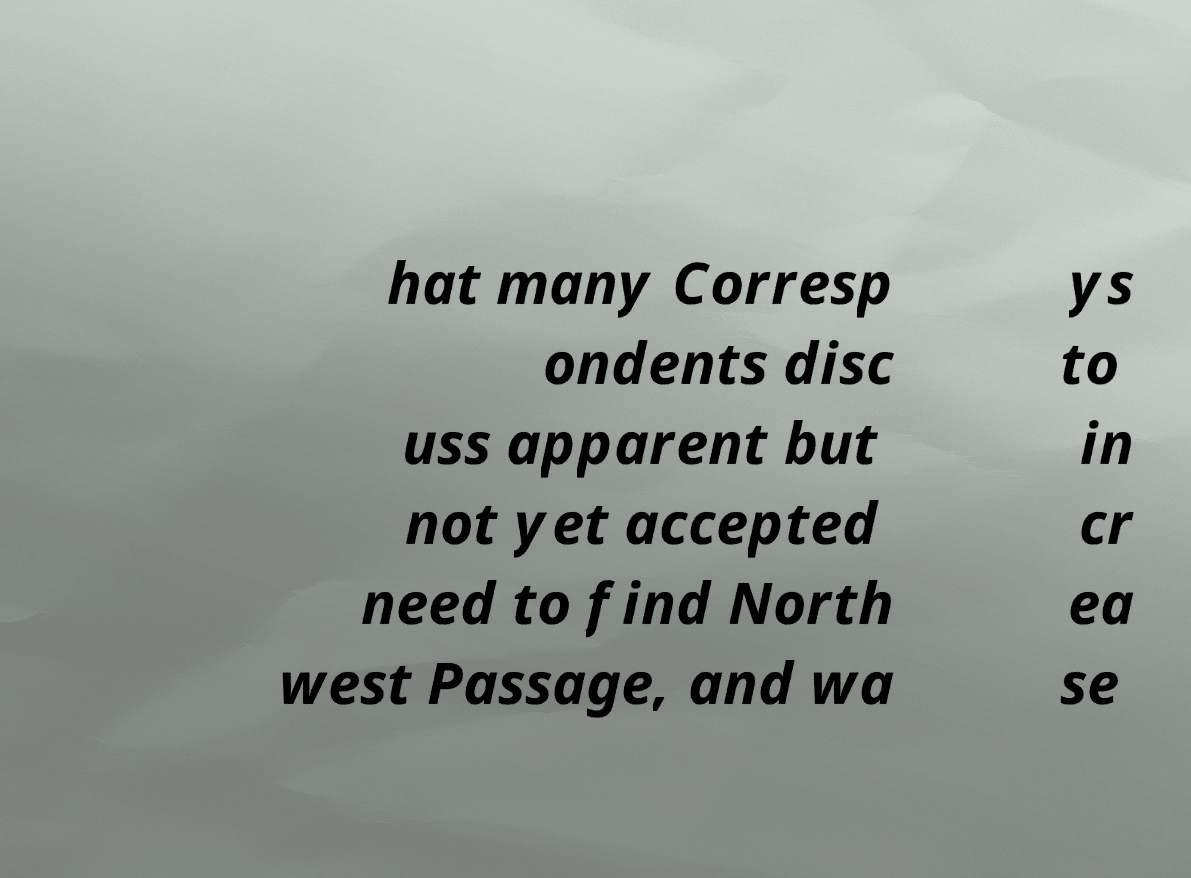Can you accurately transcribe the text from the provided image for me? hat many Corresp ondents disc uss apparent but not yet accepted need to find North west Passage, and wa ys to in cr ea se 